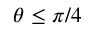<formula> <loc_0><loc_0><loc_500><loc_500>\theta \leq \pi / 4</formula> 